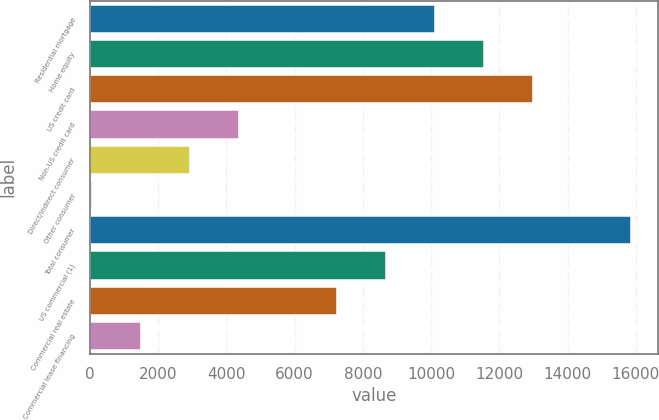Convert chart. <chart><loc_0><loc_0><loc_500><loc_500><bar_chart><fcel>Residential mortgage<fcel>Home equity<fcel>US credit card<fcel>Non-US credit card<fcel>Direct/Indirect consumer<fcel>Other consumer<fcel>Total consumer<fcel>US commercial (1)<fcel>Commercial real estate<fcel>Commercial lease financing<nl><fcel>10111<fcel>11547<fcel>12983<fcel>4367<fcel>2931<fcel>59<fcel>15855<fcel>8675<fcel>7239<fcel>1495<nl></chart> 